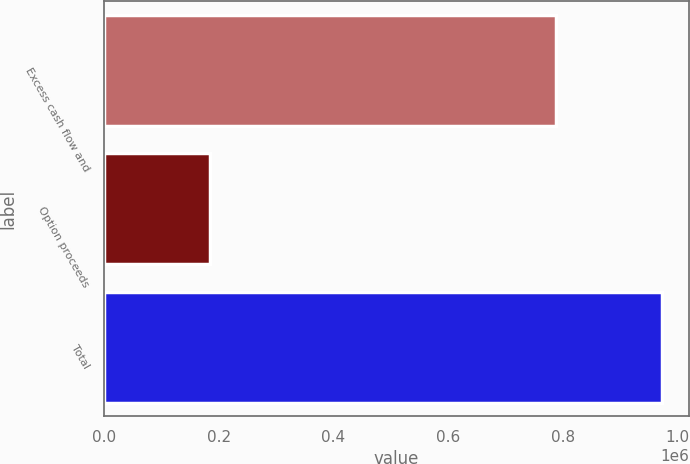<chart> <loc_0><loc_0><loc_500><loc_500><bar_chart><fcel>Excess cash flow and<fcel>Option proceeds<fcel>Total<nl><fcel>787697<fcel>184859<fcel>972556<nl></chart> 